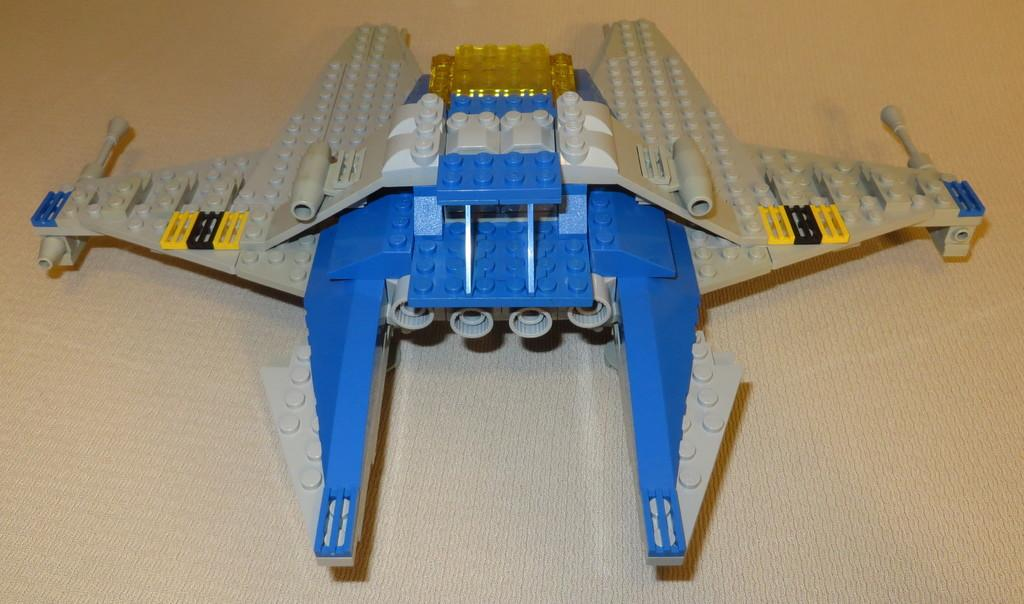What type of toy is present in the image? There is a toy ground attack aircraft in the image. Can you describe the toy in more detail? The toy is a ground attack aircraft, which is a type of military aircraft designed for close air support and ground attack missions. Who is the baseball coach in the image? There is no baseball coach present in the image, as it features a toy ground attack aircraft. 